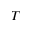Convert formula to latex. <formula><loc_0><loc_0><loc_500><loc_500>T</formula> 